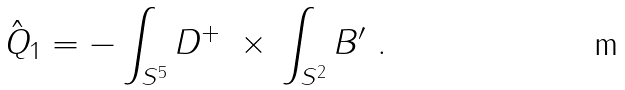Convert formula to latex. <formula><loc_0><loc_0><loc_500><loc_500>\hat { Q } _ { 1 } = - \int _ { S ^ { 5 } } D ^ { + } \ \times \, \int _ { S ^ { 2 } } B ^ { \prime } \ .</formula> 